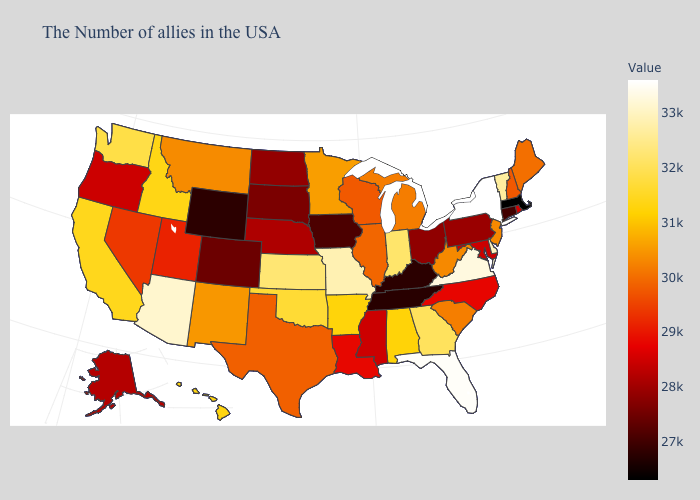Does North Dakota have a lower value than Indiana?
Answer briefly. Yes. Which states have the highest value in the USA?
Answer briefly. New York. Among the states that border Georgia , does Alabama have the lowest value?
Be succinct. No. Which states have the lowest value in the West?
Short answer required. Wyoming. Does Montana have the highest value in the West?
Give a very brief answer. No. Among the states that border West Virginia , which have the lowest value?
Keep it brief. Kentucky. Among the states that border Indiana , which have the lowest value?
Concise answer only. Kentucky. 